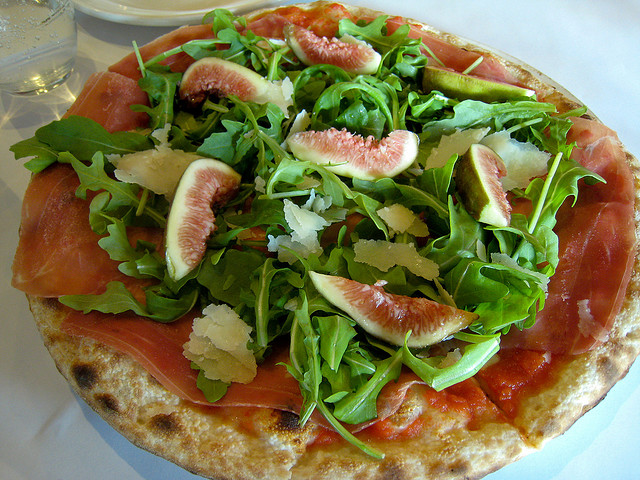<image>What fruit is on top of this pizza? I am not sure what kind of fruit is on top of the pizza. It could be figs, mango, dragon fruit, grapefruit, watermelon, or peach. What fruit is on top of this pizza? I don't know what fruit is on top of the pizza. It can be figs, mango, dragon fruit, grapefruit, watermelon, peach or none. 